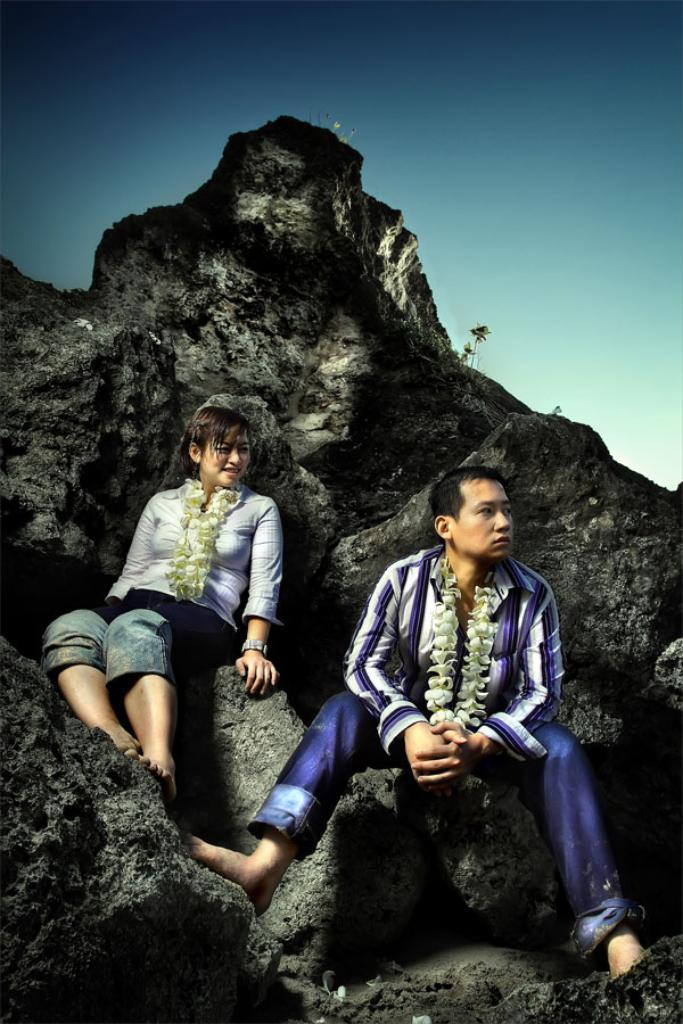How many people are in the image? There are two people in the image. What are the people doing in the image? The two people are sitting on a rock. What are the people wearing in the image? The people are wearing garlands. What type of trade is being conducted by the people on the sidewalk in the image? There is no mention of a sidewalk or trade in the image; it features two people sitting on a rock and wearing garlands. 